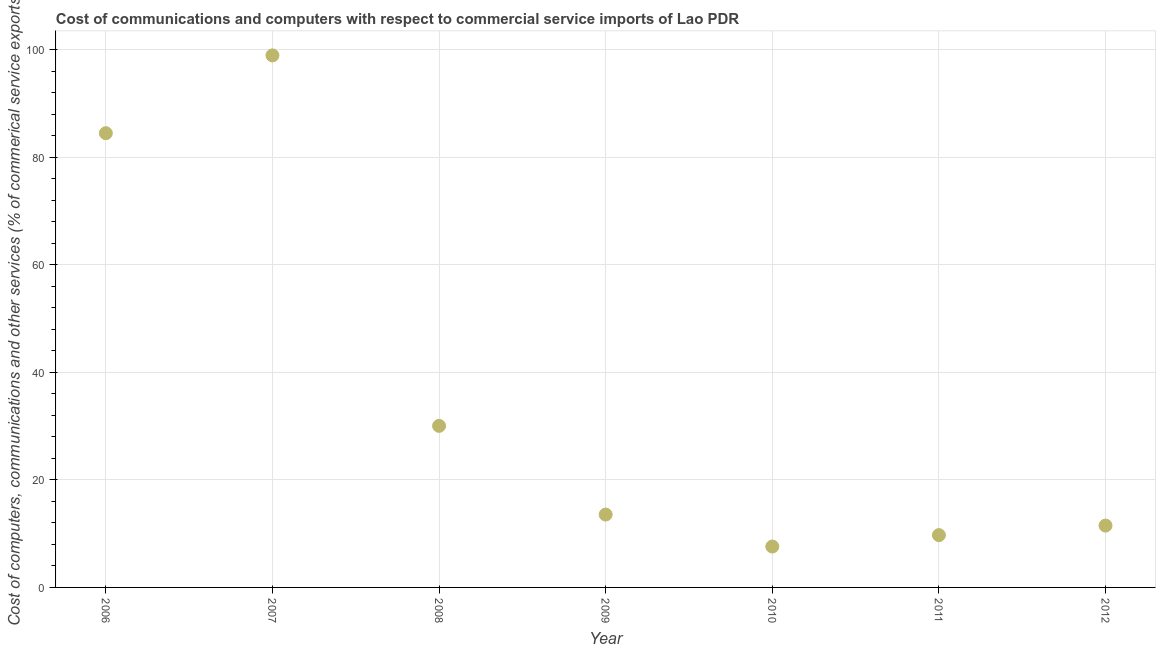What is the cost of communications in 2009?
Ensure brevity in your answer.  13.56. Across all years, what is the maximum  computer and other services?
Your answer should be compact. 98.99. Across all years, what is the minimum  computer and other services?
Offer a terse response. 7.61. In which year was the cost of communications minimum?
Your answer should be compact. 2010. What is the sum of the cost of communications?
Offer a terse response. 255.96. What is the difference between the  computer and other services in 2006 and 2010?
Ensure brevity in your answer.  76.91. What is the average cost of communications per year?
Make the answer very short. 36.57. What is the median cost of communications?
Your answer should be compact. 13.56. Do a majority of the years between 2009 and 2007 (inclusive) have  computer and other services greater than 60 %?
Ensure brevity in your answer.  No. What is the ratio of the cost of communications in 2009 to that in 2012?
Provide a succinct answer. 1.18. What is the difference between the highest and the second highest  computer and other services?
Give a very brief answer. 14.47. What is the difference between the highest and the lowest cost of communications?
Keep it short and to the point. 91.38. Does the cost of communications monotonically increase over the years?
Ensure brevity in your answer.  No. How many years are there in the graph?
Keep it short and to the point. 7. What is the difference between two consecutive major ticks on the Y-axis?
Offer a very short reply. 20. What is the title of the graph?
Your answer should be very brief. Cost of communications and computers with respect to commercial service imports of Lao PDR. What is the label or title of the X-axis?
Ensure brevity in your answer.  Year. What is the label or title of the Y-axis?
Keep it short and to the point. Cost of computers, communications and other services (% of commerical service exports). What is the Cost of computers, communications and other services (% of commerical service exports) in 2006?
Keep it short and to the point. 84.51. What is the Cost of computers, communications and other services (% of commerical service exports) in 2007?
Keep it short and to the point. 98.99. What is the Cost of computers, communications and other services (% of commerical service exports) in 2008?
Your response must be concise. 30.06. What is the Cost of computers, communications and other services (% of commerical service exports) in 2009?
Provide a succinct answer. 13.56. What is the Cost of computers, communications and other services (% of commerical service exports) in 2010?
Keep it short and to the point. 7.61. What is the Cost of computers, communications and other services (% of commerical service exports) in 2011?
Offer a terse response. 9.73. What is the Cost of computers, communications and other services (% of commerical service exports) in 2012?
Offer a very short reply. 11.5. What is the difference between the Cost of computers, communications and other services (% of commerical service exports) in 2006 and 2007?
Your response must be concise. -14.47. What is the difference between the Cost of computers, communications and other services (% of commerical service exports) in 2006 and 2008?
Your response must be concise. 54.45. What is the difference between the Cost of computers, communications and other services (% of commerical service exports) in 2006 and 2009?
Provide a short and direct response. 70.96. What is the difference between the Cost of computers, communications and other services (% of commerical service exports) in 2006 and 2010?
Provide a succinct answer. 76.91. What is the difference between the Cost of computers, communications and other services (% of commerical service exports) in 2006 and 2011?
Provide a succinct answer. 74.78. What is the difference between the Cost of computers, communications and other services (% of commerical service exports) in 2006 and 2012?
Keep it short and to the point. 73.01. What is the difference between the Cost of computers, communications and other services (% of commerical service exports) in 2007 and 2008?
Your answer should be compact. 68.93. What is the difference between the Cost of computers, communications and other services (% of commerical service exports) in 2007 and 2009?
Give a very brief answer. 85.43. What is the difference between the Cost of computers, communications and other services (% of commerical service exports) in 2007 and 2010?
Ensure brevity in your answer.  91.38. What is the difference between the Cost of computers, communications and other services (% of commerical service exports) in 2007 and 2011?
Provide a succinct answer. 89.26. What is the difference between the Cost of computers, communications and other services (% of commerical service exports) in 2007 and 2012?
Offer a terse response. 87.48. What is the difference between the Cost of computers, communications and other services (% of commerical service exports) in 2008 and 2009?
Provide a short and direct response. 16.5. What is the difference between the Cost of computers, communications and other services (% of commerical service exports) in 2008 and 2010?
Provide a short and direct response. 22.45. What is the difference between the Cost of computers, communications and other services (% of commerical service exports) in 2008 and 2011?
Keep it short and to the point. 20.33. What is the difference between the Cost of computers, communications and other services (% of commerical service exports) in 2008 and 2012?
Give a very brief answer. 18.55. What is the difference between the Cost of computers, communications and other services (% of commerical service exports) in 2009 and 2010?
Give a very brief answer. 5.95. What is the difference between the Cost of computers, communications and other services (% of commerical service exports) in 2009 and 2011?
Offer a terse response. 3.83. What is the difference between the Cost of computers, communications and other services (% of commerical service exports) in 2009 and 2012?
Ensure brevity in your answer.  2.05. What is the difference between the Cost of computers, communications and other services (% of commerical service exports) in 2010 and 2011?
Offer a very short reply. -2.12. What is the difference between the Cost of computers, communications and other services (% of commerical service exports) in 2010 and 2012?
Provide a short and direct response. -3.9. What is the difference between the Cost of computers, communications and other services (% of commerical service exports) in 2011 and 2012?
Your response must be concise. -1.77. What is the ratio of the Cost of computers, communications and other services (% of commerical service exports) in 2006 to that in 2007?
Offer a very short reply. 0.85. What is the ratio of the Cost of computers, communications and other services (% of commerical service exports) in 2006 to that in 2008?
Make the answer very short. 2.81. What is the ratio of the Cost of computers, communications and other services (% of commerical service exports) in 2006 to that in 2009?
Your answer should be very brief. 6.23. What is the ratio of the Cost of computers, communications and other services (% of commerical service exports) in 2006 to that in 2010?
Your response must be concise. 11.11. What is the ratio of the Cost of computers, communications and other services (% of commerical service exports) in 2006 to that in 2011?
Give a very brief answer. 8.69. What is the ratio of the Cost of computers, communications and other services (% of commerical service exports) in 2006 to that in 2012?
Your answer should be very brief. 7.35. What is the ratio of the Cost of computers, communications and other services (% of commerical service exports) in 2007 to that in 2008?
Your answer should be very brief. 3.29. What is the ratio of the Cost of computers, communications and other services (% of commerical service exports) in 2007 to that in 2009?
Your answer should be very brief. 7.3. What is the ratio of the Cost of computers, communications and other services (% of commerical service exports) in 2007 to that in 2010?
Your answer should be compact. 13.01. What is the ratio of the Cost of computers, communications and other services (% of commerical service exports) in 2007 to that in 2011?
Your response must be concise. 10.17. What is the ratio of the Cost of computers, communications and other services (% of commerical service exports) in 2007 to that in 2012?
Offer a terse response. 8.61. What is the ratio of the Cost of computers, communications and other services (% of commerical service exports) in 2008 to that in 2009?
Ensure brevity in your answer.  2.22. What is the ratio of the Cost of computers, communications and other services (% of commerical service exports) in 2008 to that in 2010?
Provide a succinct answer. 3.95. What is the ratio of the Cost of computers, communications and other services (% of commerical service exports) in 2008 to that in 2011?
Provide a short and direct response. 3.09. What is the ratio of the Cost of computers, communications and other services (% of commerical service exports) in 2008 to that in 2012?
Ensure brevity in your answer.  2.61. What is the ratio of the Cost of computers, communications and other services (% of commerical service exports) in 2009 to that in 2010?
Your answer should be very brief. 1.78. What is the ratio of the Cost of computers, communications and other services (% of commerical service exports) in 2009 to that in 2011?
Offer a very short reply. 1.39. What is the ratio of the Cost of computers, communications and other services (% of commerical service exports) in 2009 to that in 2012?
Make the answer very short. 1.18. What is the ratio of the Cost of computers, communications and other services (% of commerical service exports) in 2010 to that in 2011?
Keep it short and to the point. 0.78. What is the ratio of the Cost of computers, communications and other services (% of commerical service exports) in 2010 to that in 2012?
Provide a short and direct response. 0.66. What is the ratio of the Cost of computers, communications and other services (% of commerical service exports) in 2011 to that in 2012?
Give a very brief answer. 0.85. 